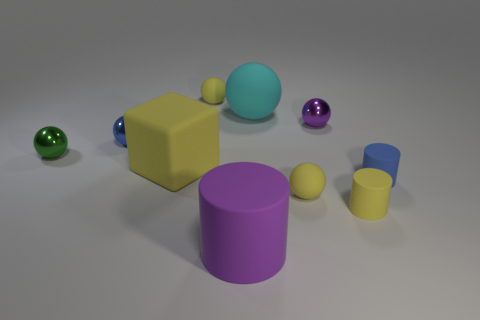Subtract 1 cylinders. How many cylinders are left? 2 Subtract all blue cylinders. How many cylinders are left? 2 Subtract 0 purple blocks. How many objects are left? 10 Subtract all cubes. How many objects are left? 9 Subtract all gray cylinders. Subtract all purple balls. How many cylinders are left? 3 Subtract all purple blocks. How many purple cylinders are left? 1 Subtract all shiny balls. Subtract all tiny blue cylinders. How many objects are left? 6 Add 3 blue metal balls. How many blue metal balls are left? 4 Add 3 yellow cylinders. How many yellow cylinders exist? 4 Subtract all blue cylinders. How many cylinders are left? 2 